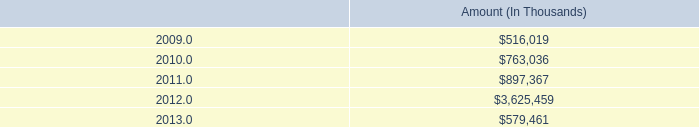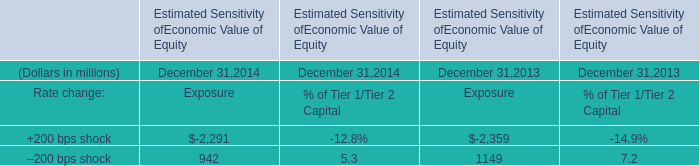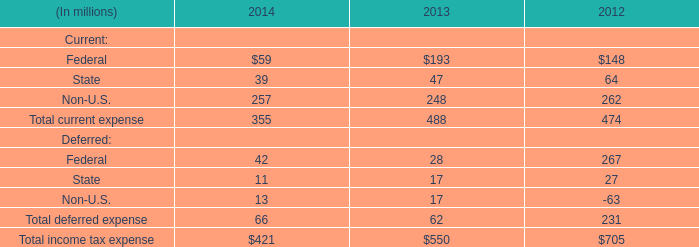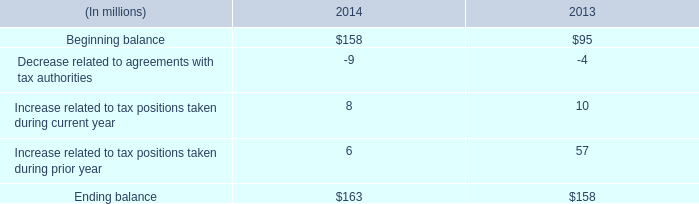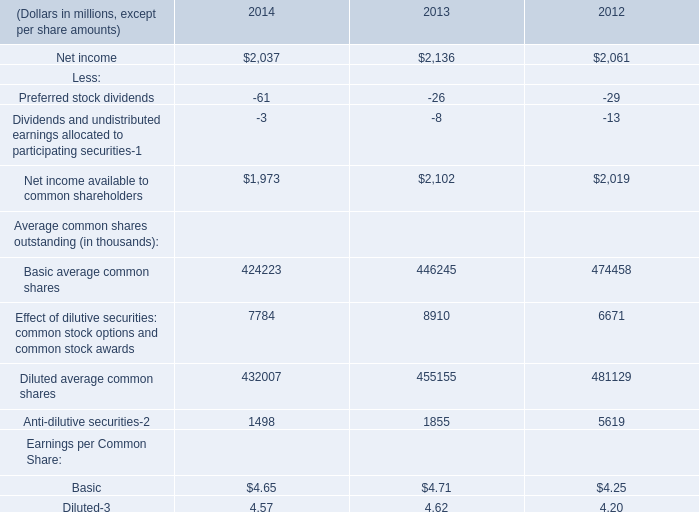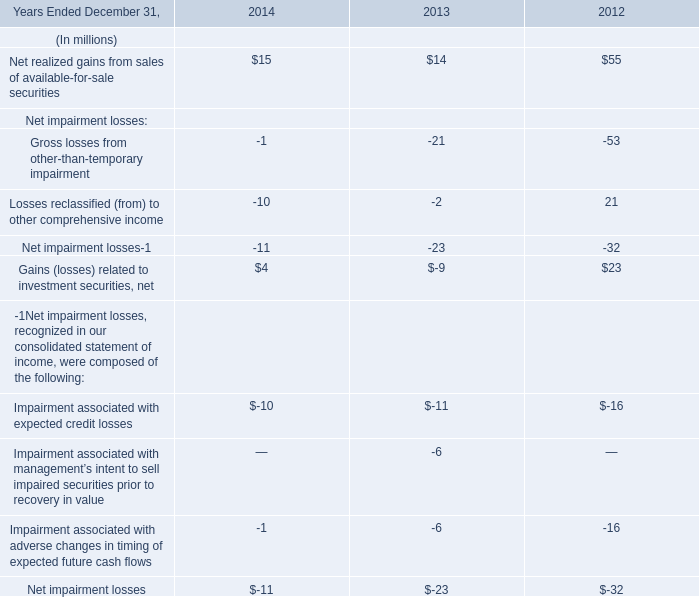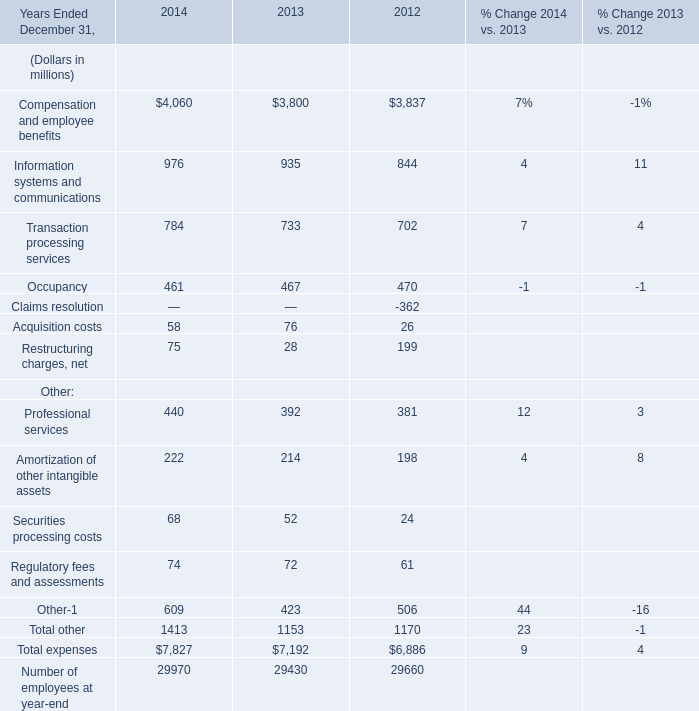What's the growth rate of Transaction processing services in 2014? 
Computations: ((784 - 733) / 733)
Answer: 0.06958. 